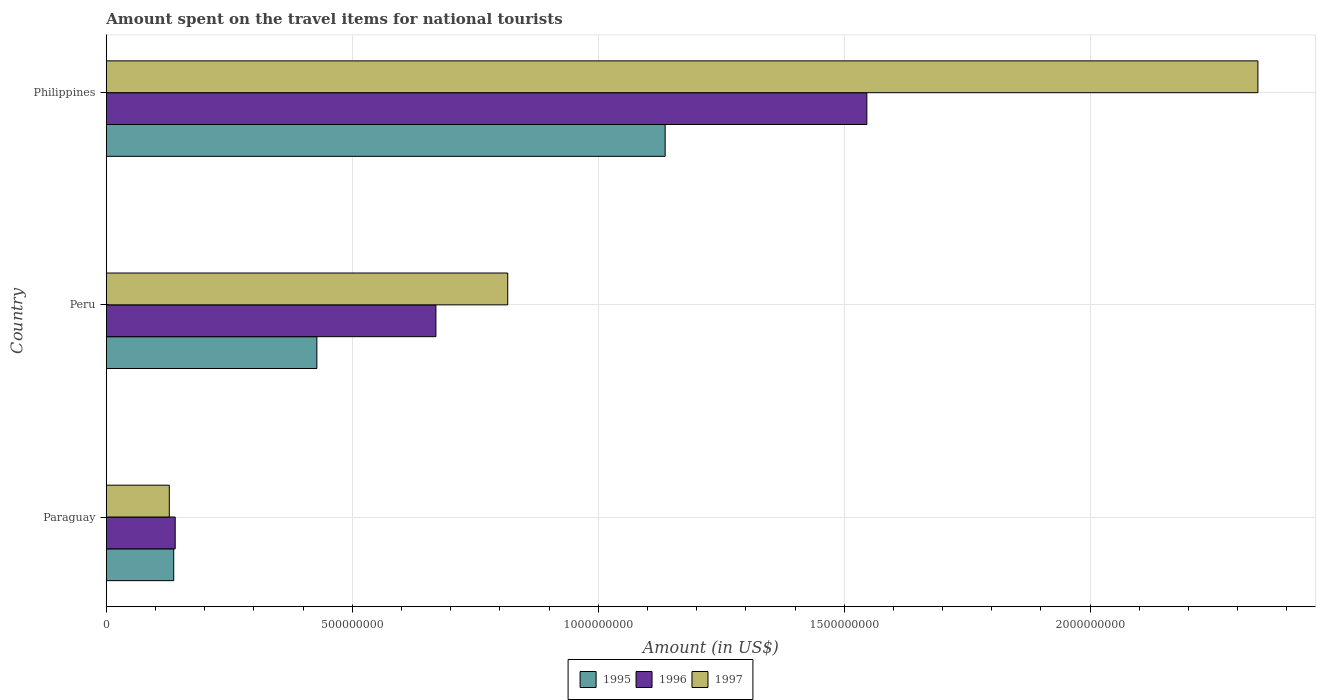How many groups of bars are there?
Your answer should be very brief. 3. Are the number of bars per tick equal to the number of legend labels?
Offer a terse response. Yes. How many bars are there on the 3rd tick from the bottom?
Offer a very short reply. 3. What is the label of the 2nd group of bars from the top?
Keep it short and to the point. Peru. What is the amount spent on the travel items for national tourists in 1995 in Peru?
Your answer should be compact. 4.28e+08. Across all countries, what is the maximum amount spent on the travel items for national tourists in 1996?
Make the answer very short. 1.55e+09. Across all countries, what is the minimum amount spent on the travel items for national tourists in 1997?
Your response must be concise. 1.28e+08. In which country was the amount spent on the travel items for national tourists in 1997 minimum?
Provide a short and direct response. Paraguay. What is the total amount spent on the travel items for national tourists in 1997 in the graph?
Provide a succinct answer. 3.28e+09. What is the difference between the amount spent on the travel items for national tourists in 1996 in Paraguay and that in Philippines?
Your answer should be compact. -1.41e+09. What is the difference between the amount spent on the travel items for national tourists in 1996 in Philippines and the amount spent on the travel items for national tourists in 1995 in Paraguay?
Your answer should be compact. 1.41e+09. What is the average amount spent on the travel items for national tourists in 1997 per country?
Give a very brief answer. 1.10e+09. What is the difference between the amount spent on the travel items for national tourists in 1996 and amount spent on the travel items for national tourists in 1997 in Paraguay?
Your response must be concise. 1.20e+07. What is the ratio of the amount spent on the travel items for national tourists in 1997 in Paraguay to that in Philippines?
Provide a succinct answer. 0.05. Is the amount spent on the travel items for national tourists in 1997 in Peru less than that in Philippines?
Provide a short and direct response. Yes. What is the difference between the highest and the second highest amount spent on the travel items for national tourists in 1997?
Ensure brevity in your answer.  1.52e+09. What is the difference between the highest and the lowest amount spent on the travel items for national tourists in 1997?
Give a very brief answer. 2.21e+09. Is the sum of the amount spent on the travel items for national tourists in 1996 in Paraguay and Philippines greater than the maximum amount spent on the travel items for national tourists in 1997 across all countries?
Offer a very short reply. No. What does the 2nd bar from the bottom in Peru represents?
Your answer should be compact. 1996. Is it the case that in every country, the sum of the amount spent on the travel items for national tourists in 1997 and amount spent on the travel items for national tourists in 1995 is greater than the amount spent on the travel items for national tourists in 1996?
Your answer should be very brief. Yes. What is the difference between two consecutive major ticks on the X-axis?
Your answer should be compact. 5.00e+08. Are the values on the major ticks of X-axis written in scientific E-notation?
Make the answer very short. No. Does the graph contain any zero values?
Your response must be concise. No. Does the graph contain grids?
Keep it short and to the point. Yes. How many legend labels are there?
Give a very brief answer. 3. What is the title of the graph?
Your answer should be compact. Amount spent on the travel items for national tourists. Does "1962" appear as one of the legend labels in the graph?
Provide a succinct answer. No. What is the label or title of the Y-axis?
Your answer should be very brief. Country. What is the Amount (in US$) in 1995 in Paraguay?
Your response must be concise. 1.37e+08. What is the Amount (in US$) in 1996 in Paraguay?
Ensure brevity in your answer.  1.40e+08. What is the Amount (in US$) in 1997 in Paraguay?
Your response must be concise. 1.28e+08. What is the Amount (in US$) in 1995 in Peru?
Offer a very short reply. 4.28e+08. What is the Amount (in US$) of 1996 in Peru?
Keep it short and to the point. 6.70e+08. What is the Amount (in US$) in 1997 in Peru?
Provide a short and direct response. 8.16e+08. What is the Amount (in US$) in 1995 in Philippines?
Offer a very short reply. 1.14e+09. What is the Amount (in US$) of 1996 in Philippines?
Give a very brief answer. 1.55e+09. What is the Amount (in US$) of 1997 in Philippines?
Offer a very short reply. 2.34e+09. Across all countries, what is the maximum Amount (in US$) in 1995?
Offer a very short reply. 1.14e+09. Across all countries, what is the maximum Amount (in US$) in 1996?
Offer a very short reply. 1.55e+09. Across all countries, what is the maximum Amount (in US$) in 1997?
Ensure brevity in your answer.  2.34e+09. Across all countries, what is the minimum Amount (in US$) in 1995?
Provide a succinct answer. 1.37e+08. Across all countries, what is the minimum Amount (in US$) in 1996?
Keep it short and to the point. 1.40e+08. Across all countries, what is the minimum Amount (in US$) of 1997?
Make the answer very short. 1.28e+08. What is the total Amount (in US$) in 1995 in the graph?
Ensure brevity in your answer.  1.70e+09. What is the total Amount (in US$) in 1996 in the graph?
Give a very brief answer. 2.36e+09. What is the total Amount (in US$) in 1997 in the graph?
Your response must be concise. 3.28e+09. What is the difference between the Amount (in US$) in 1995 in Paraguay and that in Peru?
Your response must be concise. -2.91e+08. What is the difference between the Amount (in US$) of 1996 in Paraguay and that in Peru?
Offer a terse response. -5.30e+08. What is the difference between the Amount (in US$) in 1997 in Paraguay and that in Peru?
Your answer should be very brief. -6.88e+08. What is the difference between the Amount (in US$) in 1995 in Paraguay and that in Philippines?
Keep it short and to the point. -9.99e+08. What is the difference between the Amount (in US$) in 1996 in Paraguay and that in Philippines?
Your response must be concise. -1.41e+09. What is the difference between the Amount (in US$) of 1997 in Paraguay and that in Philippines?
Provide a succinct answer. -2.21e+09. What is the difference between the Amount (in US$) in 1995 in Peru and that in Philippines?
Give a very brief answer. -7.08e+08. What is the difference between the Amount (in US$) in 1996 in Peru and that in Philippines?
Ensure brevity in your answer.  -8.76e+08. What is the difference between the Amount (in US$) of 1997 in Peru and that in Philippines?
Provide a succinct answer. -1.52e+09. What is the difference between the Amount (in US$) in 1995 in Paraguay and the Amount (in US$) in 1996 in Peru?
Offer a very short reply. -5.33e+08. What is the difference between the Amount (in US$) in 1995 in Paraguay and the Amount (in US$) in 1997 in Peru?
Give a very brief answer. -6.79e+08. What is the difference between the Amount (in US$) of 1996 in Paraguay and the Amount (in US$) of 1997 in Peru?
Provide a succinct answer. -6.76e+08. What is the difference between the Amount (in US$) in 1995 in Paraguay and the Amount (in US$) in 1996 in Philippines?
Your answer should be very brief. -1.41e+09. What is the difference between the Amount (in US$) of 1995 in Paraguay and the Amount (in US$) of 1997 in Philippines?
Ensure brevity in your answer.  -2.20e+09. What is the difference between the Amount (in US$) of 1996 in Paraguay and the Amount (in US$) of 1997 in Philippines?
Offer a very short reply. -2.20e+09. What is the difference between the Amount (in US$) of 1995 in Peru and the Amount (in US$) of 1996 in Philippines?
Offer a terse response. -1.12e+09. What is the difference between the Amount (in US$) in 1995 in Peru and the Amount (in US$) in 1997 in Philippines?
Your answer should be very brief. -1.91e+09. What is the difference between the Amount (in US$) of 1996 in Peru and the Amount (in US$) of 1997 in Philippines?
Offer a terse response. -1.67e+09. What is the average Amount (in US$) of 1995 per country?
Your response must be concise. 5.67e+08. What is the average Amount (in US$) in 1996 per country?
Ensure brevity in your answer.  7.85e+08. What is the average Amount (in US$) of 1997 per country?
Keep it short and to the point. 1.10e+09. What is the difference between the Amount (in US$) of 1995 and Amount (in US$) of 1996 in Paraguay?
Offer a terse response. -3.00e+06. What is the difference between the Amount (in US$) in 1995 and Amount (in US$) in 1997 in Paraguay?
Offer a very short reply. 9.00e+06. What is the difference between the Amount (in US$) of 1996 and Amount (in US$) of 1997 in Paraguay?
Keep it short and to the point. 1.20e+07. What is the difference between the Amount (in US$) in 1995 and Amount (in US$) in 1996 in Peru?
Provide a short and direct response. -2.42e+08. What is the difference between the Amount (in US$) in 1995 and Amount (in US$) in 1997 in Peru?
Provide a short and direct response. -3.88e+08. What is the difference between the Amount (in US$) in 1996 and Amount (in US$) in 1997 in Peru?
Ensure brevity in your answer.  -1.46e+08. What is the difference between the Amount (in US$) of 1995 and Amount (in US$) of 1996 in Philippines?
Provide a short and direct response. -4.10e+08. What is the difference between the Amount (in US$) in 1995 and Amount (in US$) in 1997 in Philippines?
Ensure brevity in your answer.  -1.20e+09. What is the difference between the Amount (in US$) of 1996 and Amount (in US$) of 1997 in Philippines?
Keep it short and to the point. -7.95e+08. What is the ratio of the Amount (in US$) in 1995 in Paraguay to that in Peru?
Make the answer very short. 0.32. What is the ratio of the Amount (in US$) in 1996 in Paraguay to that in Peru?
Offer a terse response. 0.21. What is the ratio of the Amount (in US$) of 1997 in Paraguay to that in Peru?
Provide a succinct answer. 0.16. What is the ratio of the Amount (in US$) of 1995 in Paraguay to that in Philippines?
Make the answer very short. 0.12. What is the ratio of the Amount (in US$) of 1996 in Paraguay to that in Philippines?
Your response must be concise. 0.09. What is the ratio of the Amount (in US$) in 1997 in Paraguay to that in Philippines?
Keep it short and to the point. 0.05. What is the ratio of the Amount (in US$) of 1995 in Peru to that in Philippines?
Ensure brevity in your answer.  0.38. What is the ratio of the Amount (in US$) of 1996 in Peru to that in Philippines?
Offer a very short reply. 0.43. What is the ratio of the Amount (in US$) in 1997 in Peru to that in Philippines?
Offer a very short reply. 0.35. What is the difference between the highest and the second highest Amount (in US$) in 1995?
Offer a terse response. 7.08e+08. What is the difference between the highest and the second highest Amount (in US$) in 1996?
Your answer should be very brief. 8.76e+08. What is the difference between the highest and the second highest Amount (in US$) of 1997?
Your answer should be very brief. 1.52e+09. What is the difference between the highest and the lowest Amount (in US$) in 1995?
Provide a short and direct response. 9.99e+08. What is the difference between the highest and the lowest Amount (in US$) in 1996?
Give a very brief answer. 1.41e+09. What is the difference between the highest and the lowest Amount (in US$) of 1997?
Your answer should be very brief. 2.21e+09. 